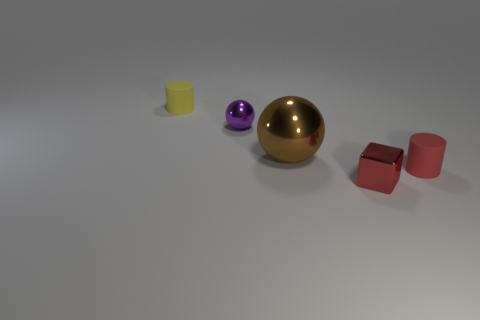Add 1 balls. How many objects exist? 6 Subtract all blocks. How many objects are left? 4 Add 4 gray matte balls. How many gray matte balls exist? 4 Subtract 1 yellow cylinders. How many objects are left? 4 Subtract all tiny shiny things. Subtract all small red shiny blocks. How many objects are left? 2 Add 5 purple metal objects. How many purple metal objects are left? 6 